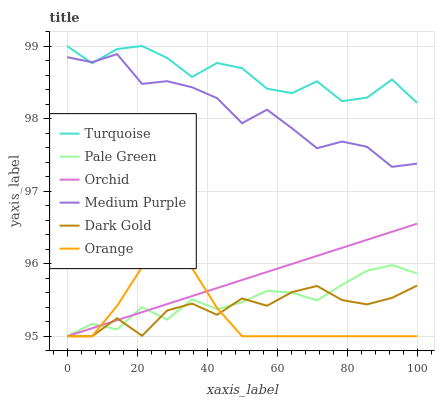Does Orange have the minimum area under the curve?
Answer yes or no. Yes. Does Turquoise have the maximum area under the curve?
Answer yes or no. Yes. Does Dark Gold have the minimum area under the curve?
Answer yes or no. No. Does Dark Gold have the maximum area under the curve?
Answer yes or no. No. Is Orchid the smoothest?
Answer yes or no. Yes. Is Turquoise the roughest?
Answer yes or no. Yes. Is Dark Gold the smoothest?
Answer yes or no. No. Is Dark Gold the roughest?
Answer yes or no. No. Does Dark Gold have the lowest value?
Answer yes or no. Yes. Does Medium Purple have the lowest value?
Answer yes or no. No. Does Turquoise have the highest value?
Answer yes or no. Yes. Does Medium Purple have the highest value?
Answer yes or no. No. Is Dark Gold less than Turquoise?
Answer yes or no. Yes. Is Medium Purple greater than Pale Green?
Answer yes or no. Yes. Does Orchid intersect Pale Green?
Answer yes or no. Yes. Is Orchid less than Pale Green?
Answer yes or no. No. Is Orchid greater than Pale Green?
Answer yes or no. No. Does Dark Gold intersect Turquoise?
Answer yes or no. No. 